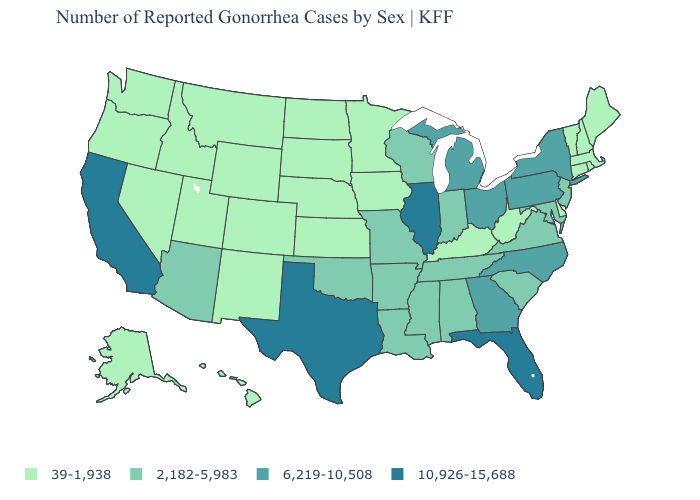Does the first symbol in the legend represent the smallest category?
Give a very brief answer. Yes. What is the lowest value in the USA?
Concise answer only. 39-1,938. Name the states that have a value in the range 39-1,938?
Be succinct. Alaska, Colorado, Connecticut, Delaware, Hawaii, Idaho, Iowa, Kansas, Kentucky, Maine, Massachusetts, Minnesota, Montana, Nebraska, Nevada, New Hampshire, New Mexico, North Dakota, Oregon, Rhode Island, South Dakota, Utah, Vermont, Washington, West Virginia, Wyoming. Does Vermont have a lower value than Tennessee?
Write a very short answer. Yes. Does the first symbol in the legend represent the smallest category?
Short answer required. Yes. Which states hav the highest value in the South?
Answer briefly. Florida, Texas. Does Florida have the highest value in the USA?
Give a very brief answer. Yes. Does Washington have the same value as Florida?
Concise answer only. No. What is the lowest value in the West?
Answer briefly. 39-1,938. What is the highest value in the USA?
Answer briefly. 10,926-15,688. Does New York have the lowest value in the USA?
Quick response, please. No. Among the states that border South Carolina , which have the lowest value?
Short answer required. Georgia, North Carolina. Among the states that border Nevada , does Arizona have the lowest value?
Give a very brief answer. No. 